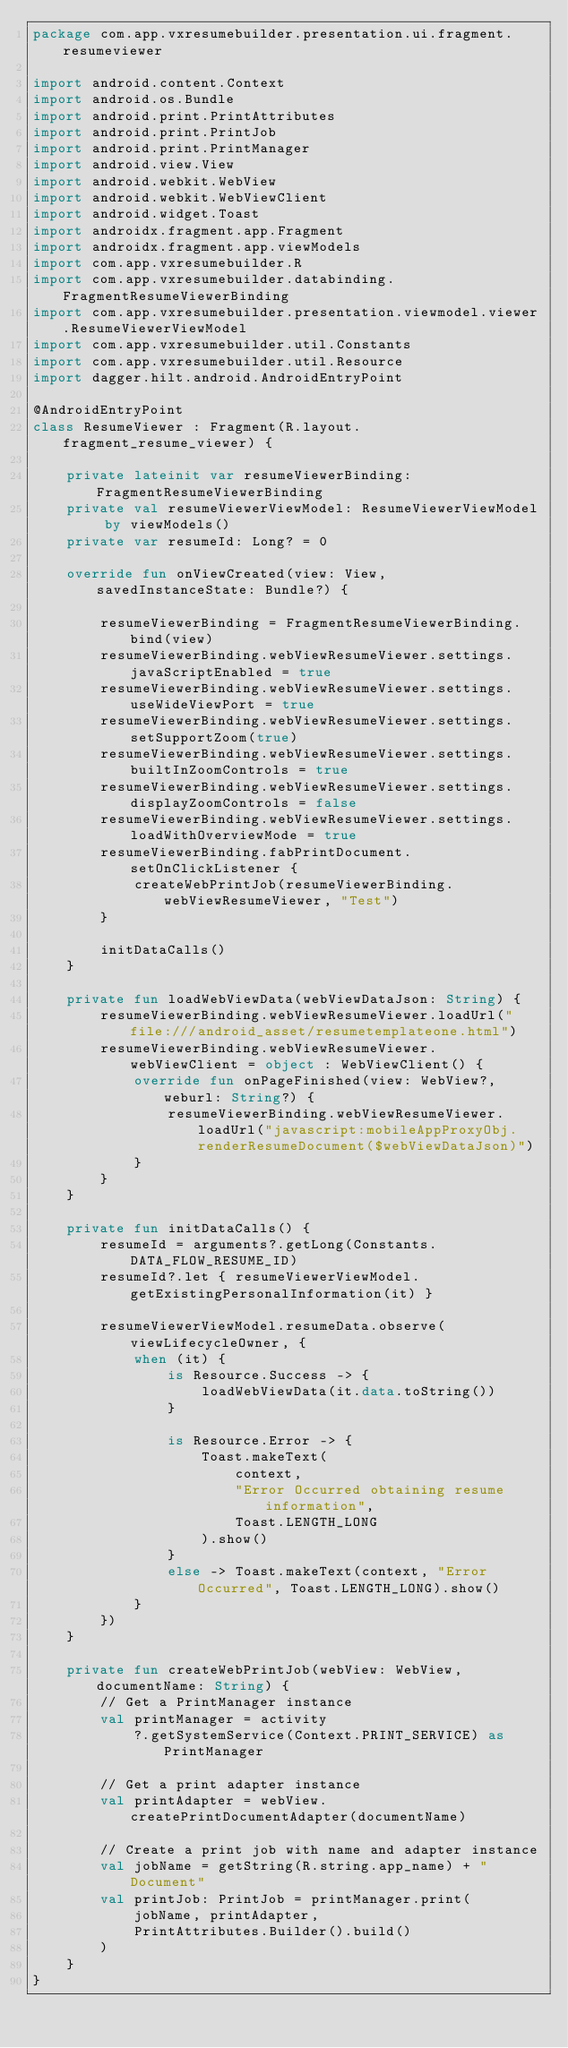<code> <loc_0><loc_0><loc_500><loc_500><_Kotlin_>package com.app.vxresumebuilder.presentation.ui.fragment.resumeviewer

import android.content.Context
import android.os.Bundle
import android.print.PrintAttributes
import android.print.PrintJob
import android.print.PrintManager
import android.view.View
import android.webkit.WebView
import android.webkit.WebViewClient
import android.widget.Toast
import androidx.fragment.app.Fragment
import androidx.fragment.app.viewModels
import com.app.vxresumebuilder.R
import com.app.vxresumebuilder.databinding.FragmentResumeViewerBinding
import com.app.vxresumebuilder.presentation.viewmodel.viewer.ResumeViewerViewModel
import com.app.vxresumebuilder.util.Constants
import com.app.vxresumebuilder.util.Resource
import dagger.hilt.android.AndroidEntryPoint

@AndroidEntryPoint
class ResumeViewer : Fragment(R.layout.fragment_resume_viewer) {

    private lateinit var resumeViewerBinding: FragmentResumeViewerBinding
    private val resumeViewerViewModel: ResumeViewerViewModel by viewModels()
    private var resumeId: Long? = 0

    override fun onViewCreated(view: View, savedInstanceState: Bundle?) {

        resumeViewerBinding = FragmentResumeViewerBinding.bind(view)
        resumeViewerBinding.webViewResumeViewer.settings.javaScriptEnabled = true
        resumeViewerBinding.webViewResumeViewer.settings.useWideViewPort = true
        resumeViewerBinding.webViewResumeViewer.settings.setSupportZoom(true)
        resumeViewerBinding.webViewResumeViewer.settings.builtInZoomControls = true
        resumeViewerBinding.webViewResumeViewer.settings.displayZoomControls = false
        resumeViewerBinding.webViewResumeViewer.settings.loadWithOverviewMode = true
        resumeViewerBinding.fabPrintDocument.setOnClickListener {
            createWebPrintJob(resumeViewerBinding.webViewResumeViewer, "Test")
        }

        initDataCalls()
    }

    private fun loadWebViewData(webViewDataJson: String) {
        resumeViewerBinding.webViewResumeViewer.loadUrl("file:///android_asset/resumetemplateone.html")
        resumeViewerBinding.webViewResumeViewer.webViewClient = object : WebViewClient() {
            override fun onPageFinished(view: WebView?, weburl: String?) {
                resumeViewerBinding.webViewResumeViewer.loadUrl("javascript:mobileAppProxyObj.renderResumeDocument($webViewDataJson)")
            }
        }
    }

    private fun initDataCalls() {
        resumeId = arguments?.getLong(Constants.DATA_FLOW_RESUME_ID)
        resumeId?.let { resumeViewerViewModel.getExistingPersonalInformation(it) }

        resumeViewerViewModel.resumeData.observe(viewLifecycleOwner, {
            when (it) {
                is Resource.Success -> {
                    loadWebViewData(it.data.toString())
                }

                is Resource.Error -> {
                    Toast.makeText(
                        context,
                        "Error Occurred obtaining resume information",
                        Toast.LENGTH_LONG
                    ).show()
                }
                else -> Toast.makeText(context, "Error Occurred", Toast.LENGTH_LONG).show()
            }
        })
    }

    private fun createWebPrintJob(webView: WebView, documentName: String) {
        // Get a PrintManager instance
        val printManager = activity
            ?.getSystemService(Context.PRINT_SERVICE) as PrintManager

        // Get a print adapter instance
        val printAdapter = webView.createPrintDocumentAdapter(documentName)

        // Create a print job with name and adapter instance
        val jobName = getString(R.string.app_name) + " Document"
        val printJob: PrintJob = printManager.print(
            jobName, printAdapter,
            PrintAttributes.Builder().build()
        )
    }
}
</code> 